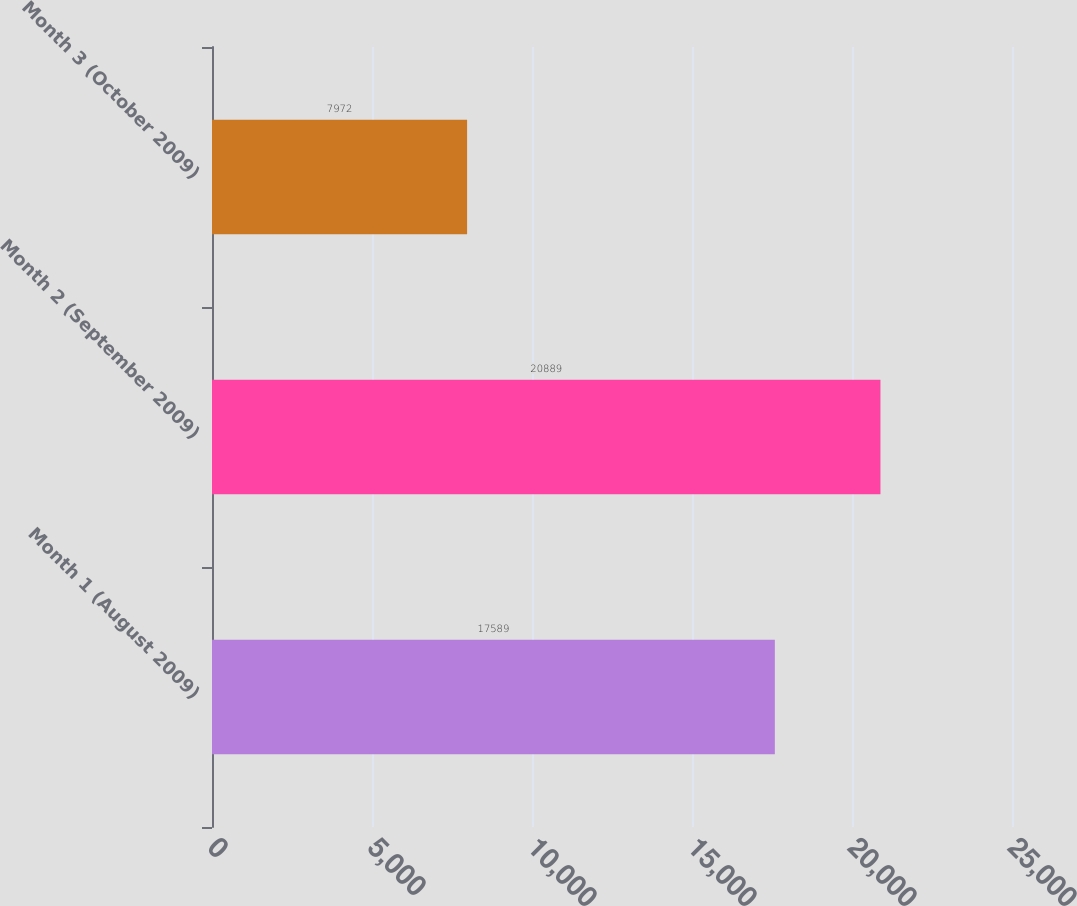Convert chart. <chart><loc_0><loc_0><loc_500><loc_500><bar_chart><fcel>Month 1 (August 2009)<fcel>Month 2 (September 2009)<fcel>Month 3 (October 2009)<nl><fcel>17589<fcel>20889<fcel>7972<nl></chart> 